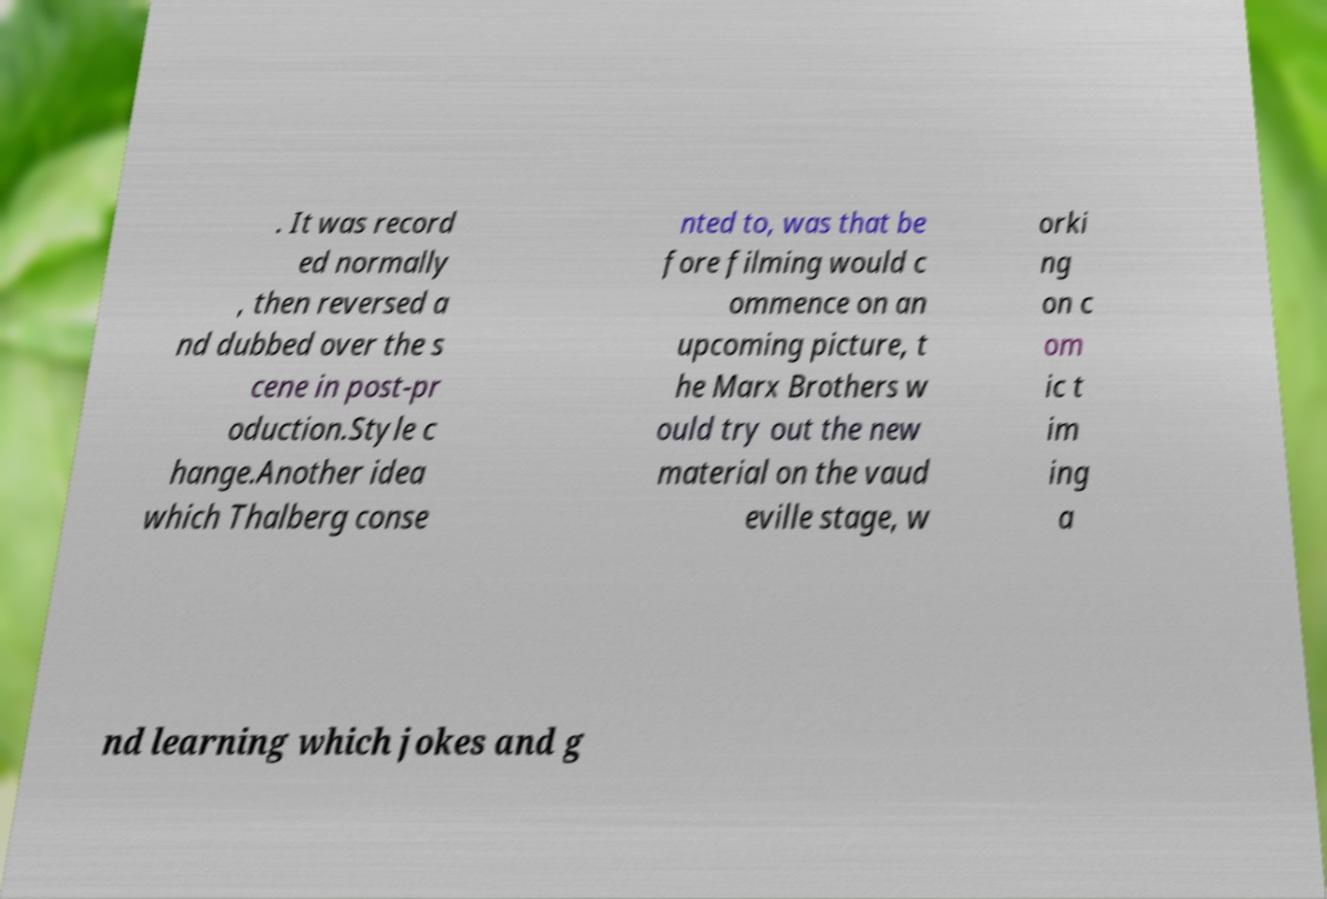Could you extract and type out the text from this image? . It was record ed normally , then reversed a nd dubbed over the s cene in post-pr oduction.Style c hange.Another idea which Thalberg conse nted to, was that be fore filming would c ommence on an upcoming picture, t he Marx Brothers w ould try out the new material on the vaud eville stage, w orki ng on c om ic t im ing a nd learning which jokes and g 